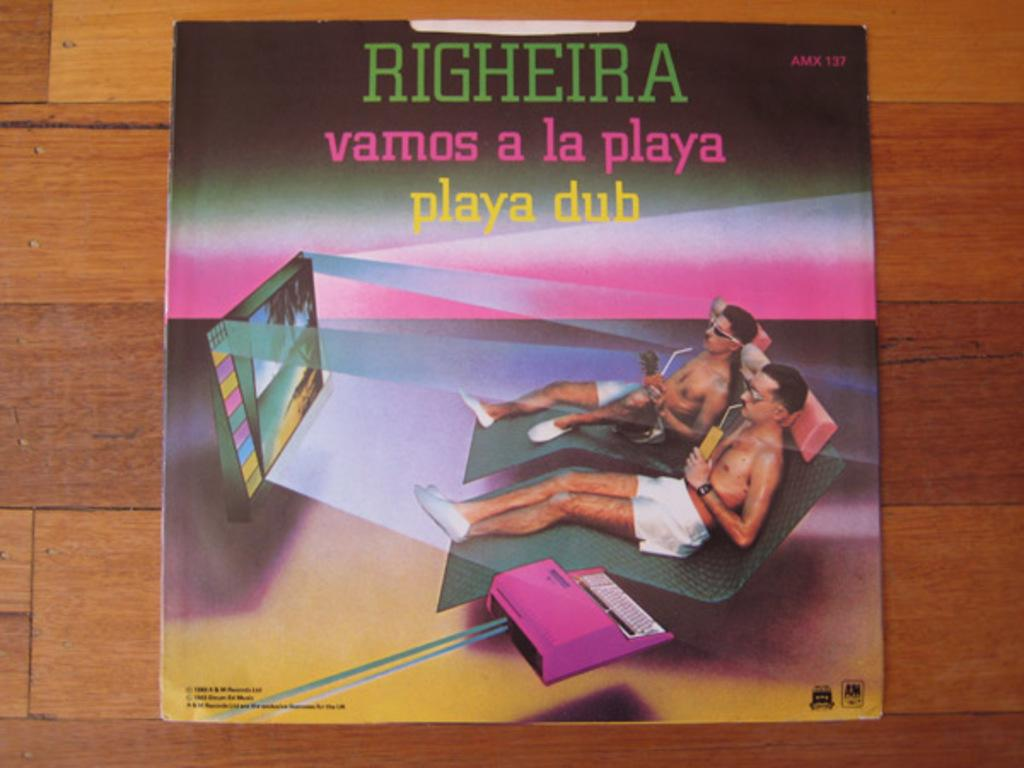<image>
Create a compact narrative representing the image presented. A CD cover for Righeira vamos a la playa. 